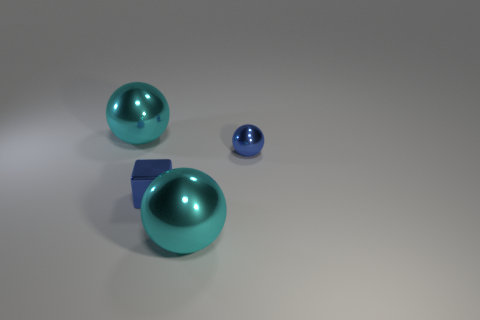Add 3 blue things. How many objects exist? 7 Subtract all cubes. How many objects are left? 3 Add 1 tiny blue spheres. How many tiny blue spheres are left? 2 Add 3 big cyan metallic things. How many big cyan metallic things exist? 5 Subtract 0 cyan blocks. How many objects are left? 4 Subtract all small balls. Subtract all gray shiny objects. How many objects are left? 3 